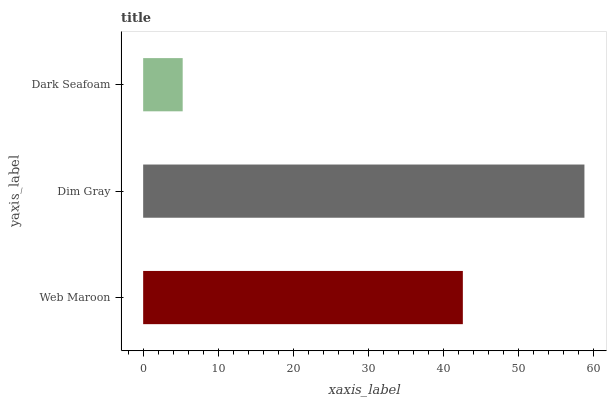Is Dark Seafoam the minimum?
Answer yes or no. Yes. Is Dim Gray the maximum?
Answer yes or no. Yes. Is Dim Gray the minimum?
Answer yes or no. No. Is Dark Seafoam the maximum?
Answer yes or no. No. Is Dim Gray greater than Dark Seafoam?
Answer yes or no. Yes. Is Dark Seafoam less than Dim Gray?
Answer yes or no. Yes. Is Dark Seafoam greater than Dim Gray?
Answer yes or no. No. Is Dim Gray less than Dark Seafoam?
Answer yes or no. No. Is Web Maroon the high median?
Answer yes or no. Yes. Is Web Maroon the low median?
Answer yes or no. Yes. Is Dim Gray the high median?
Answer yes or no. No. Is Dark Seafoam the low median?
Answer yes or no. No. 